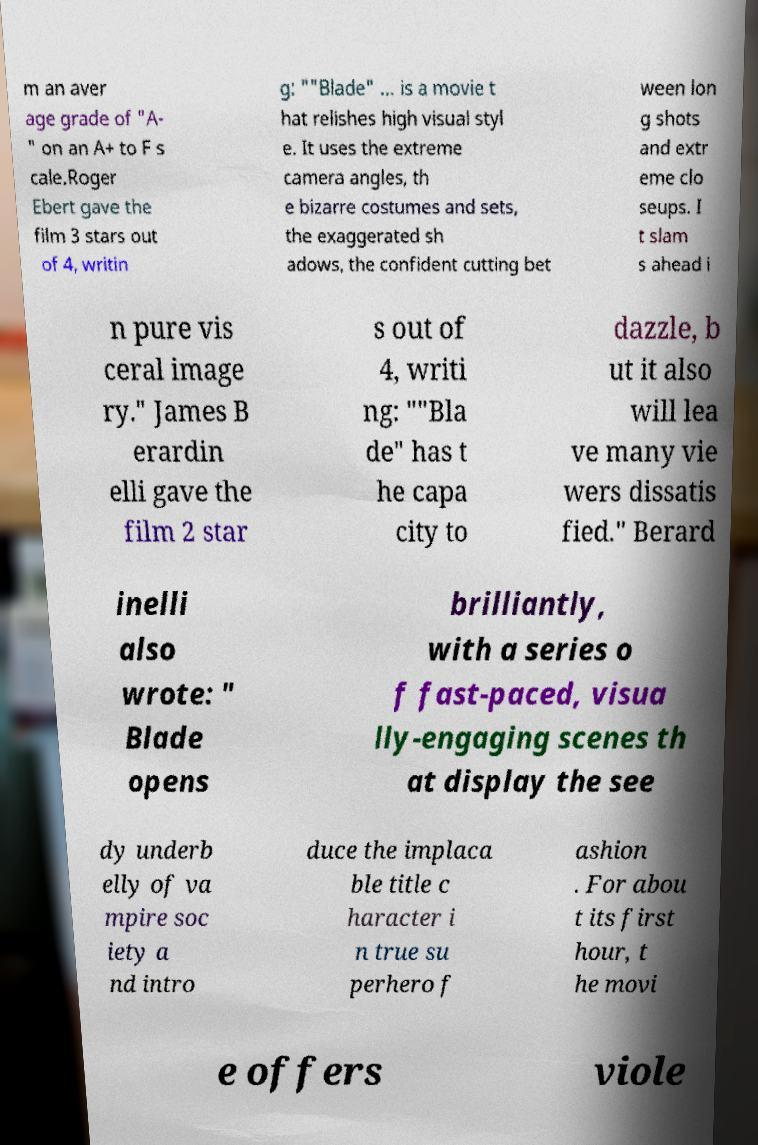There's text embedded in this image that I need extracted. Can you transcribe it verbatim? m an aver age grade of "A- " on an A+ to F s cale.Roger Ebert gave the film 3 stars out of 4, writin g: ""Blade" ... is a movie t hat relishes high visual styl e. It uses the extreme camera angles, th e bizarre costumes and sets, the exaggerated sh adows, the confident cutting bet ween lon g shots and extr eme clo seups. I t slam s ahead i n pure vis ceral image ry." James B erardin elli gave the film 2 star s out of 4, writi ng: ""Bla de" has t he capa city to dazzle, b ut it also will lea ve many vie wers dissatis fied." Berard inelli also wrote: " Blade opens brilliantly, with a series o f fast-paced, visua lly-engaging scenes th at display the see dy underb elly of va mpire soc iety a nd intro duce the implaca ble title c haracter i n true su perhero f ashion . For abou t its first hour, t he movi e offers viole 